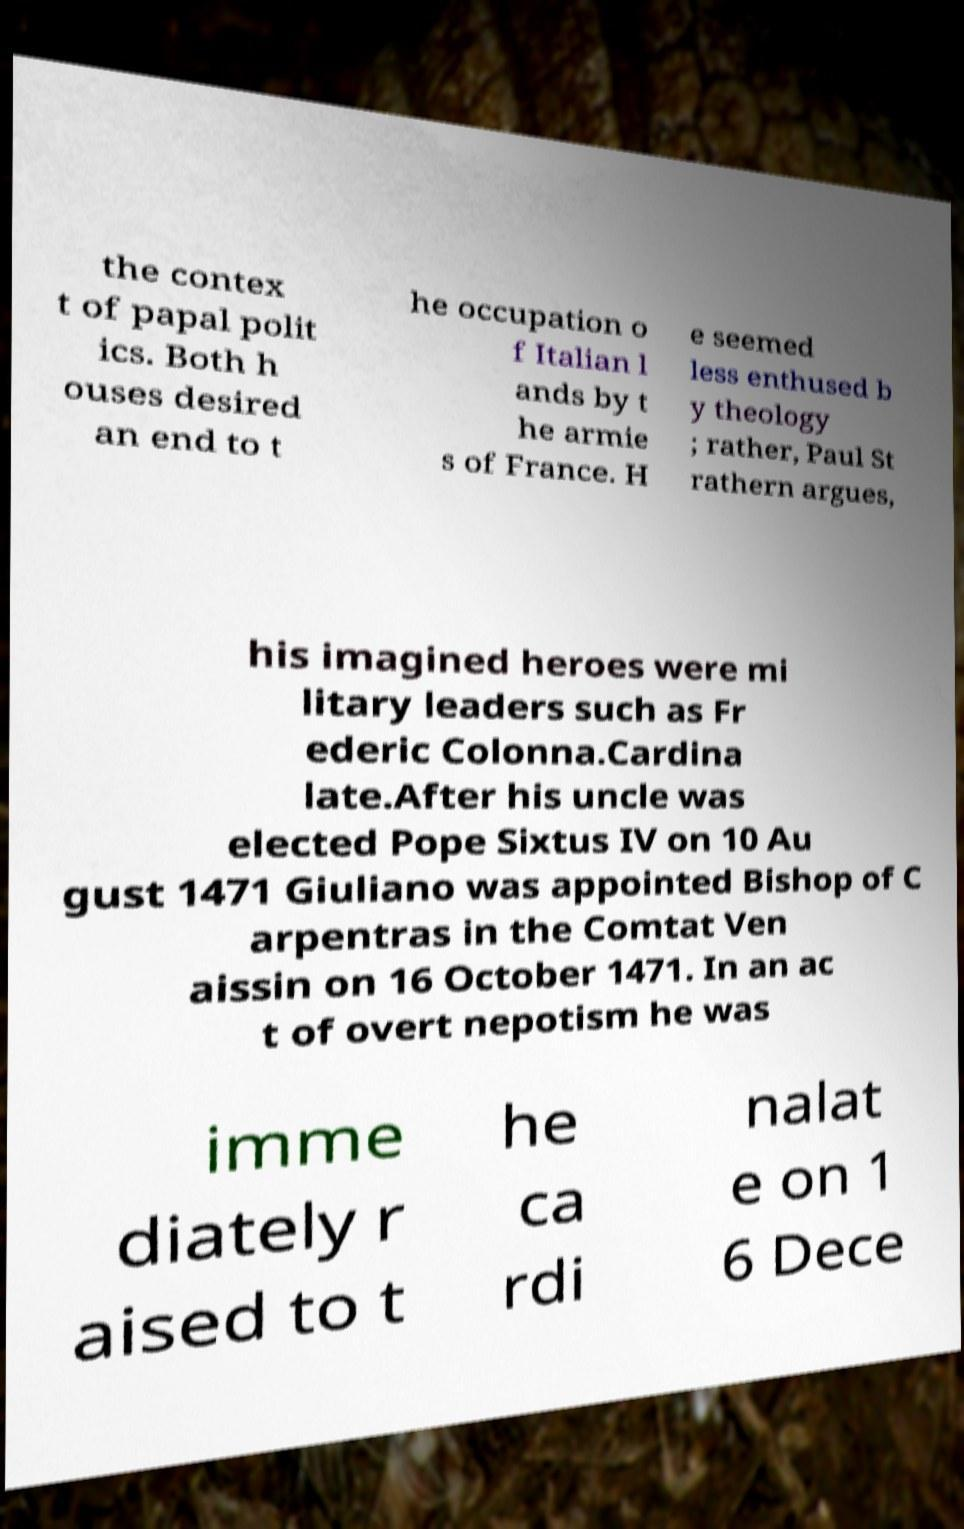There's text embedded in this image that I need extracted. Can you transcribe it verbatim? the contex t of papal polit ics. Both h ouses desired an end to t he occupation o f Italian l ands by t he armie s of France. H e seemed less enthused b y theology ; rather, Paul St rathern argues, his imagined heroes were mi litary leaders such as Fr ederic Colonna.Cardina late.After his uncle was elected Pope Sixtus IV on 10 Au gust 1471 Giuliano was appointed Bishop of C arpentras in the Comtat Ven aissin on 16 October 1471. In an ac t of overt nepotism he was imme diately r aised to t he ca rdi nalat e on 1 6 Dece 